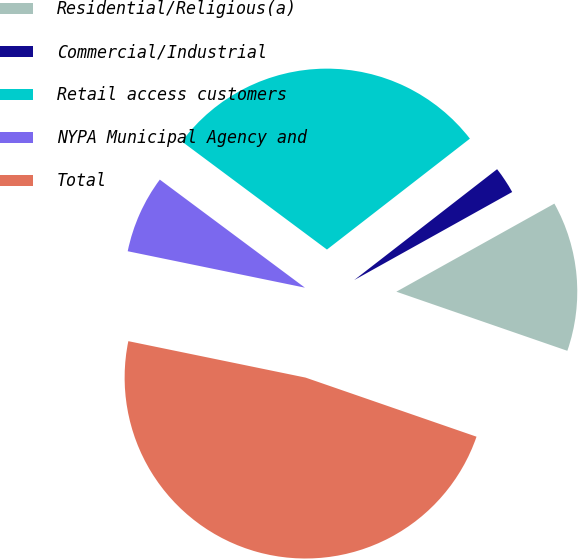<chart> <loc_0><loc_0><loc_500><loc_500><pie_chart><fcel>Residential/Religious(a)<fcel>Commercial/Industrial<fcel>Retail access customers<fcel>NYPA Municipal Agency and<fcel>Total<nl><fcel>13.39%<fcel>2.41%<fcel>29.31%<fcel>6.96%<fcel>47.93%<nl></chart> 